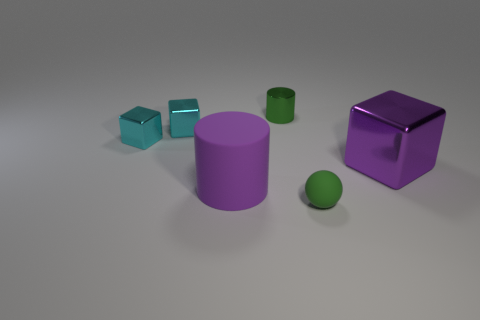Do the big object that is on the right side of the green rubber ball and the purple thing that is on the left side of the sphere have the same material? Based on the image, the large object on the right side of the green rubber ball appears to be a cylinder made of a matte material, whereas the purple object on the left side of the ball looks like a cube also with a matte finish. However, while both objects seem to have similar materials with matte finishes, without more contextual information, such as texture close-ups or knowledge about the intention of the object's design, we can't definitively say they are the same material. They simply share a similar visual characteristic in this image. 